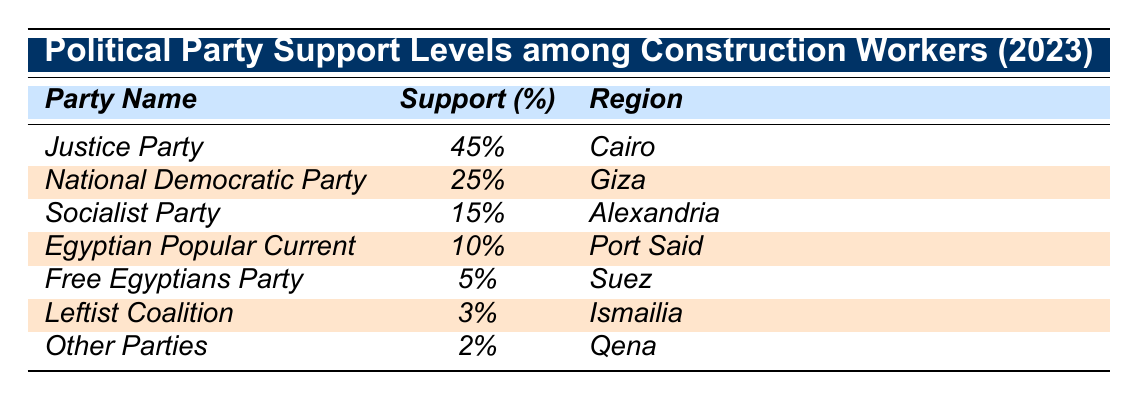What is the support percentage for the Justice Party among construction workers? The support percentage for the Justice Party is directly listed in the table as 45%.
Answer: 45% Which political party has the lowest support among construction workers? The political party with the lowest support, according to the table, is the Other Parties with a support percentage of 2%.
Answer: Other Parties How much more support does the Justice Party have compared to the Free Egyptians Party? The Justice Party has 45% support, while the Free Egyptians Party has 5%. The difference is 45% - 5% = 40%.
Answer: 40% What is the total support percentage of the National Democratic Party and Socialist Party combined? The National Democratic Party has 25% support, and the Socialist Party has 15% support. Their combined support is 25% + 15% = 40%.
Answer: 40% Is the support for the Leftist Coalition greater than the support for the Egyptian Popular Current? The Leftist Coalition has 3% support, while the Egyptian Popular Current has 10%. Since 3% is less than 10%, the statement is false.
Answer: No Which region has the highest percentage of construction worker support for a political party? According to the table, Cairo has the highest support for the Justice Party at 45%.
Answer: Cairo If we arrange the political parties by support percentage from highest to lowest, what would be the fourth party on that list? The parties in order are: Justice Party (45%), National Democratic Party (25%), Socialist Party (15%), and then the Egyptian Popular Current (10%). Thus, the fourth party is the Egyptian Popular Current.
Answer: Egyptian Popular Current What percentage of construction workers support parties other than those listed in the table? To find that, we add the support percentages in the table which total to 100%. Since the table only lists the parties, the percentage for other parties cannot be determined from the provided data. Thus, it’s 0% or the sum minus those listed.
Answer: 0% (implied) How much support does the Socialist Party have compared to the combined support of the Leftist Coalition and Other Parties? The Socialist Party has 15% support, while the Leftist Coalition has 3% and Other Parties have 2%. Combined, leftist parties have 3% + 2% = 5%. Therefore, the Socialist Party has 15% - 5% = 10% more than the combined support.
Answer: 10% Which political party has support greater than 10% and is located in Giza? The National Democratic Party has 25% support and is located in Giza, which is greater than 10%.
Answer: National Democratic Party 